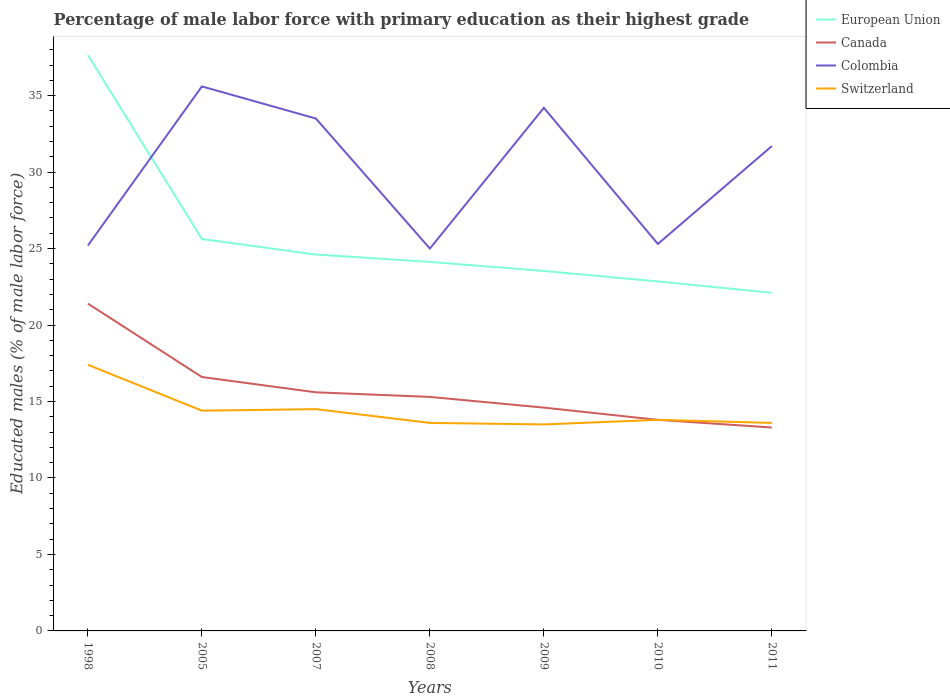Is the number of lines equal to the number of legend labels?
Offer a very short reply. Yes. Across all years, what is the maximum percentage of male labor force with primary education in European Union?
Offer a terse response. 22.11. What is the total percentage of male labor force with primary education in Canada in the graph?
Ensure brevity in your answer.  1.3. What is the difference between the highest and the second highest percentage of male labor force with primary education in Switzerland?
Offer a terse response. 3.9. What is the difference between the highest and the lowest percentage of male labor force with primary education in Colombia?
Provide a short and direct response. 4. Is the percentage of male labor force with primary education in Colombia strictly greater than the percentage of male labor force with primary education in European Union over the years?
Give a very brief answer. No. How many lines are there?
Your answer should be very brief. 4. How many years are there in the graph?
Provide a succinct answer. 7. Does the graph contain any zero values?
Make the answer very short. No. Does the graph contain grids?
Provide a short and direct response. No. Where does the legend appear in the graph?
Give a very brief answer. Top right. How are the legend labels stacked?
Provide a succinct answer. Vertical. What is the title of the graph?
Your answer should be compact. Percentage of male labor force with primary education as their highest grade. What is the label or title of the X-axis?
Your answer should be compact. Years. What is the label or title of the Y-axis?
Keep it short and to the point. Educated males (% of male labor force). What is the Educated males (% of male labor force) in European Union in 1998?
Offer a terse response. 37.64. What is the Educated males (% of male labor force) in Canada in 1998?
Your answer should be compact. 21.4. What is the Educated males (% of male labor force) in Colombia in 1998?
Make the answer very short. 25.2. What is the Educated males (% of male labor force) of Switzerland in 1998?
Your answer should be compact. 17.4. What is the Educated males (% of male labor force) in European Union in 2005?
Give a very brief answer. 25.62. What is the Educated males (% of male labor force) in Canada in 2005?
Offer a very short reply. 16.6. What is the Educated males (% of male labor force) in Colombia in 2005?
Provide a short and direct response. 35.6. What is the Educated males (% of male labor force) in Switzerland in 2005?
Give a very brief answer. 14.4. What is the Educated males (% of male labor force) of European Union in 2007?
Offer a terse response. 24.61. What is the Educated males (% of male labor force) of Canada in 2007?
Provide a succinct answer. 15.6. What is the Educated males (% of male labor force) in Colombia in 2007?
Provide a succinct answer. 33.5. What is the Educated males (% of male labor force) of European Union in 2008?
Your response must be concise. 24.13. What is the Educated males (% of male labor force) in Canada in 2008?
Your response must be concise. 15.3. What is the Educated males (% of male labor force) in Colombia in 2008?
Your answer should be compact. 25. What is the Educated males (% of male labor force) of Switzerland in 2008?
Ensure brevity in your answer.  13.6. What is the Educated males (% of male labor force) in European Union in 2009?
Make the answer very short. 23.53. What is the Educated males (% of male labor force) of Canada in 2009?
Ensure brevity in your answer.  14.6. What is the Educated males (% of male labor force) of Colombia in 2009?
Offer a very short reply. 34.2. What is the Educated males (% of male labor force) in European Union in 2010?
Provide a short and direct response. 22.85. What is the Educated males (% of male labor force) in Canada in 2010?
Your answer should be compact. 13.8. What is the Educated males (% of male labor force) of Colombia in 2010?
Give a very brief answer. 25.3. What is the Educated males (% of male labor force) in Switzerland in 2010?
Make the answer very short. 13.8. What is the Educated males (% of male labor force) in European Union in 2011?
Provide a short and direct response. 22.11. What is the Educated males (% of male labor force) in Canada in 2011?
Make the answer very short. 13.3. What is the Educated males (% of male labor force) of Colombia in 2011?
Provide a short and direct response. 31.7. What is the Educated males (% of male labor force) of Switzerland in 2011?
Your answer should be very brief. 13.6. Across all years, what is the maximum Educated males (% of male labor force) of European Union?
Make the answer very short. 37.64. Across all years, what is the maximum Educated males (% of male labor force) of Canada?
Offer a terse response. 21.4. Across all years, what is the maximum Educated males (% of male labor force) in Colombia?
Ensure brevity in your answer.  35.6. Across all years, what is the maximum Educated males (% of male labor force) of Switzerland?
Offer a terse response. 17.4. Across all years, what is the minimum Educated males (% of male labor force) of European Union?
Keep it short and to the point. 22.11. Across all years, what is the minimum Educated males (% of male labor force) in Canada?
Offer a very short reply. 13.3. What is the total Educated males (% of male labor force) of European Union in the graph?
Provide a short and direct response. 180.48. What is the total Educated males (% of male labor force) in Canada in the graph?
Your response must be concise. 110.6. What is the total Educated males (% of male labor force) of Colombia in the graph?
Your answer should be very brief. 210.5. What is the total Educated males (% of male labor force) in Switzerland in the graph?
Your answer should be very brief. 100.8. What is the difference between the Educated males (% of male labor force) of European Union in 1998 and that in 2005?
Your response must be concise. 12.02. What is the difference between the Educated males (% of male labor force) of Canada in 1998 and that in 2005?
Keep it short and to the point. 4.8. What is the difference between the Educated males (% of male labor force) in Colombia in 1998 and that in 2005?
Provide a succinct answer. -10.4. What is the difference between the Educated males (% of male labor force) in European Union in 1998 and that in 2007?
Give a very brief answer. 13.04. What is the difference between the Educated males (% of male labor force) of Canada in 1998 and that in 2007?
Give a very brief answer. 5.8. What is the difference between the Educated males (% of male labor force) of Switzerland in 1998 and that in 2007?
Your answer should be very brief. 2.9. What is the difference between the Educated males (% of male labor force) in European Union in 1998 and that in 2008?
Your answer should be compact. 13.52. What is the difference between the Educated males (% of male labor force) of Colombia in 1998 and that in 2008?
Make the answer very short. 0.2. What is the difference between the Educated males (% of male labor force) of Switzerland in 1998 and that in 2008?
Your answer should be very brief. 3.8. What is the difference between the Educated males (% of male labor force) of European Union in 1998 and that in 2009?
Keep it short and to the point. 14.11. What is the difference between the Educated males (% of male labor force) of Canada in 1998 and that in 2009?
Provide a short and direct response. 6.8. What is the difference between the Educated males (% of male labor force) in Colombia in 1998 and that in 2009?
Ensure brevity in your answer.  -9. What is the difference between the Educated males (% of male labor force) of European Union in 1998 and that in 2010?
Give a very brief answer. 14.79. What is the difference between the Educated males (% of male labor force) in Canada in 1998 and that in 2010?
Provide a succinct answer. 7.6. What is the difference between the Educated males (% of male labor force) in Colombia in 1998 and that in 2010?
Offer a very short reply. -0.1. What is the difference between the Educated males (% of male labor force) in Switzerland in 1998 and that in 2010?
Make the answer very short. 3.6. What is the difference between the Educated males (% of male labor force) in European Union in 1998 and that in 2011?
Make the answer very short. 15.54. What is the difference between the Educated males (% of male labor force) of European Union in 2005 and that in 2007?
Offer a terse response. 1.02. What is the difference between the Educated males (% of male labor force) in Switzerland in 2005 and that in 2007?
Make the answer very short. -0.1. What is the difference between the Educated males (% of male labor force) of European Union in 2005 and that in 2008?
Offer a very short reply. 1.5. What is the difference between the Educated males (% of male labor force) of Canada in 2005 and that in 2008?
Provide a succinct answer. 1.3. What is the difference between the Educated males (% of male labor force) in European Union in 2005 and that in 2009?
Ensure brevity in your answer.  2.09. What is the difference between the Educated males (% of male labor force) of Colombia in 2005 and that in 2009?
Ensure brevity in your answer.  1.4. What is the difference between the Educated males (% of male labor force) of Switzerland in 2005 and that in 2009?
Your answer should be very brief. 0.9. What is the difference between the Educated males (% of male labor force) of European Union in 2005 and that in 2010?
Offer a very short reply. 2.78. What is the difference between the Educated males (% of male labor force) in Canada in 2005 and that in 2010?
Your response must be concise. 2.8. What is the difference between the Educated males (% of male labor force) of Switzerland in 2005 and that in 2010?
Make the answer very short. 0.6. What is the difference between the Educated males (% of male labor force) of European Union in 2005 and that in 2011?
Keep it short and to the point. 3.52. What is the difference between the Educated males (% of male labor force) of Canada in 2005 and that in 2011?
Give a very brief answer. 3.3. What is the difference between the Educated males (% of male labor force) in European Union in 2007 and that in 2008?
Offer a very short reply. 0.48. What is the difference between the Educated males (% of male labor force) in Colombia in 2007 and that in 2008?
Provide a short and direct response. 8.5. What is the difference between the Educated males (% of male labor force) in Switzerland in 2007 and that in 2008?
Provide a short and direct response. 0.9. What is the difference between the Educated males (% of male labor force) of European Union in 2007 and that in 2009?
Give a very brief answer. 1.07. What is the difference between the Educated males (% of male labor force) in European Union in 2007 and that in 2010?
Offer a very short reply. 1.76. What is the difference between the Educated males (% of male labor force) of Canada in 2007 and that in 2010?
Offer a very short reply. 1.8. What is the difference between the Educated males (% of male labor force) in Colombia in 2007 and that in 2010?
Offer a terse response. 8.2. What is the difference between the Educated males (% of male labor force) in Switzerland in 2007 and that in 2010?
Ensure brevity in your answer.  0.7. What is the difference between the Educated males (% of male labor force) of European Union in 2007 and that in 2011?
Provide a succinct answer. 2.5. What is the difference between the Educated males (% of male labor force) of European Union in 2008 and that in 2009?
Keep it short and to the point. 0.59. What is the difference between the Educated males (% of male labor force) in Colombia in 2008 and that in 2009?
Your answer should be compact. -9.2. What is the difference between the Educated males (% of male labor force) of European Union in 2008 and that in 2010?
Make the answer very short. 1.28. What is the difference between the Educated males (% of male labor force) of Switzerland in 2008 and that in 2010?
Ensure brevity in your answer.  -0.2. What is the difference between the Educated males (% of male labor force) of European Union in 2008 and that in 2011?
Provide a succinct answer. 2.02. What is the difference between the Educated males (% of male labor force) of Canada in 2008 and that in 2011?
Offer a terse response. 2. What is the difference between the Educated males (% of male labor force) of European Union in 2009 and that in 2010?
Your response must be concise. 0.69. What is the difference between the Educated males (% of male labor force) in Canada in 2009 and that in 2010?
Make the answer very short. 0.8. What is the difference between the Educated males (% of male labor force) in European Union in 2009 and that in 2011?
Offer a terse response. 1.43. What is the difference between the Educated males (% of male labor force) of Canada in 2009 and that in 2011?
Offer a very short reply. 1.3. What is the difference between the Educated males (% of male labor force) of Switzerland in 2009 and that in 2011?
Provide a short and direct response. -0.1. What is the difference between the Educated males (% of male labor force) in European Union in 2010 and that in 2011?
Your answer should be very brief. 0.74. What is the difference between the Educated males (% of male labor force) of European Union in 1998 and the Educated males (% of male labor force) of Canada in 2005?
Provide a short and direct response. 21.04. What is the difference between the Educated males (% of male labor force) of European Union in 1998 and the Educated males (% of male labor force) of Colombia in 2005?
Your answer should be compact. 2.04. What is the difference between the Educated males (% of male labor force) of European Union in 1998 and the Educated males (% of male labor force) of Switzerland in 2005?
Ensure brevity in your answer.  23.24. What is the difference between the Educated males (% of male labor force) in European Union in 1998 and the Educated males (% of male labor force) in Canada in 2007?
Keep it short and to the point. 22.04. What is the difference between the Educated males (% of male labor force) in European Union in 1998 and the Educated males (% of male labor force) in Colombia in 2007?
Offer a terse response. 4.14. What is the difference between the Educated males (% of male labor force) of European Union in 1998 and the Educated males (% of male labor force) of Switzerland in 2007?
Provide a short and direct response. 23.14. What is the difference between the Educated males (% of male labor force) of European Union in 1998 and the Educated males (% of male labor force) of Canada in 2008?
Give a very brief answer. 22.34. What is the difference between the Educated males (% of male labor force) in European Union in 1998 and the Educated males (% of male labor force) in Colombia in 2008?
Your answer should be very brief. 12.64. What is the difference between the Educated males (% of male labor force) in European Union in 1998 and the Educated males (% of male labor force) in Switzerland in 2008?
Ensure brevity in your answer.  24.04. What is the difference between the Educated males (% of male labor force) in Canada in 1998 and the Educated males (% of male labor force) in Colombia in 2008?
Offer a very short reply. -3.6. What is the difference between the Educated males (% of male labor force) of Colombia in 1998 and the Educated males (% of male labor force) of Switzerland in 2008?
Offer a very short reply. 11.6. What is the difference between the Educated males (% of male labor force) in European Union in 1998 and the Educated males (% of male labor force) in Canada in 2009?
Make the answer very short. 23.04. What is the difference between the Educated males (% of male labor force) of European Union in 1998 and the Educated males (% of male labor force) of Colombia in 2009?
Your answer should be compact. 3.44. What is the difference between the Educated males (% of male labor force) of European Union in 1998 and the Educated males (% of male labor force) of Switzerland in 2009?
Provide a succinct answer. 24.14. What is the difference between the Educated males (% of male labor force) of Colombia in 1998 and the Educated males (% of male labor force) of Switzerland in 2009?
Offer a very short reply. 11.7. What is the difference between the Educated males (% of male labor force) in European Union in 1998 and the Educated males (% of male labor force) in Canada in 2010?
Ensure brevity in your answer.  23.84. What is the difference between the Educated males (% of male labor force) in European Union in 1998 and the Educated males (% of male labor force) in Colombia in 2010?
Offer a very short reply. 12.34. What is the difference between the Educated males (% of male labor force) of European Union in 1998 and the Educated males (% of male labor force) of Switzerland in 2010?
Ensure brevity in your answer.  23.84. What is the difference between the Educated males (% of male labor force) in Canada in 1998 and the Educated males (% of male labor force) in Colombia in 2010?
Provide a succinct answer. -3.9. What is the difference between the Educated males (% of male labor force) of Colombia in 1998 and the Educated males (% of male labor force) of Switzerland in 2010?
Your answer should be very brief. 11.4. What is the difference between the Educated males (% of male labor force) in European Union in 1998 and the Educated males (% of male labor force) in Canada in 2011?
Your response must be concise. 24.34. What is the difference between the Educated males (% of male labor force) in European Union in 1998 and the Educated males (% of male labor force) in Colombia in 2011?
Your answer should be compact. 5.94. What is the difference between the Educated males (% of male labor force) in European Union in 1998 and the Educated males (% of male labor force) in Switzerland in 2011?
Your answer should be compact. 24.04. What is the difference between the Educated males (% of male labor force) of Canada in 1998 and the Educated males (% of male labor force) of Switzerland in 2011?
Ensure brevity in your answer.  7.8. What is the difference between the Educated males (% of male labor force) of European Union in 2005 and the Educated males (% of male labor force) of Canada in 2007?
Give a very brief answer. 10.02. What is the difference between the Educated males (% of male labor force) of European Union in 2005 and the Educated males (% of male labor force) of Colombia in 2007?
Ensure brevity in your answer.  -7.88. What is the difference between the Educated males (% of male labor force) of European Union in 2005 and the Educated males (% of male labor force) of Switzerland in 2007?
Provide a short and direct response. 11.12. What is the difference between the Educated males (% of male labor force) in Canada in 2005 and the Educated males (% of male labor force) in Colombia in 2007?
Provide a short and direct response. -16.9. What is the difference between the Educated males (% of male labor force) of Canada in 2005 and the Educated males (% of male labor force) of Switzerland in 2007?
Your answer should be very brief. 2.1. What is the difference between the Educated males (% of male labor force) of Colombia in 2005 and the Educated males (% of male labor force) of Switzerland in 2007?
Offer a very short reply. 21.1. What is the difference between the Educated males (% of male labor force) of European Union in 2005 and the Educated males (% of male labor force) of Canada in 2008?
Make the answer very short. 10.32. What is the difference between the Educated males (% of male labor force) of European Union in 2005 and the Educated males (% of male labor force) of Colombia in 2008?
Make the answer very short. 0.62. What is the difference between the Educated males (% of male labor force) in European Union in 2005 and the Educated males (% of male labor force) in Switzerland in 2008?
Make the answer very short. 12.02. What is the difference between the Educated males (% of male labor force) in Canada in 2005 and the Educated males (% of male labor force) in Colombia in 2008?
Give a very brief answer. -8.4. What is the difference between the Educated males (% of male labor force) of Canada in 2005 and the Educated males (% of male labor force) of Switzerland in 2008?
Provide a short and direct response. 3. What is the difference between the Educated males (% of male labor force) in European Union in 2005 and the Educated males (% of male labor force) in Canada in 2009?
Your response must be concise. 11.02. What is the difference between the Educated males (% of male labor force) in European Union in 2005 and the Educated males (% of male labor force) in Colombia in 2009?
Offer a terse response. -8.58. What is the difference between the Educated males (% of male labor force) of European Union in 2005 and the Educated males (% of male labor force) of Switzerland in 2009?
Your answer should be very brief. 12.12. What is the difference between the Educated males (% of male labor force) in Canada in 2005 and the Educated males (% of male labor force) in Colombia in 2009?
Your answer should be compact. -17.6. What is the difference between the Educated males (% of male labor force) of Canada in 2005 and the Educated males (% of male labor force) of Switzerland in 2009?
Make the answer very short. 3.1. What is the difference between the Educated males (% of male labor force) of Colombia in 2005 and the Educated males (% of male labor force) of Switzerland in 2009?
Offer a terse response. 22.1. What is the difference between the Educated males (% of male labor force) in European Union in 2005 and the Educated males (% of male labor force) in Canada in 2010?
Give a very brief answer. 11.82. What is the difference between the Educated males (% of male labor force) in European Union in 2005 and the Educated males (% of male labor force) in Colombia in 2010?
Ensure brevity in your answer.  0.32. What is the difference between the Educated males (% of male labor force) in European Union in 2005 and the Educated males (% of male labor force) in Switzerland in 2010?
Provide a short and direct response. 11.82. What is the difference between the Educated males (% of male labor force) in Canada in 2005 and the Educated males (% of male labor force) in Colombia in 2010?
Make the answer very short. -8.7. What is the difference between the Educated males (% of male labor force) of Colombia in 2005 and the Educated males (% of male labor force) of Switzerland in 2010?
Make the answer very short. 21.8. What is the difference between the Educated males (% of male labor force) of European Union in 2005 and the Educated males (% of male labor force) of Canada in 2011?
Your answer should be very brief. 12.32. What is the difference between the Educated males (% of male labor force) in European Union in 2005 and the Educated males (% of male labor force) in Colombia in 2011?
Ensure brevity in your answer.  -6.08. What is the difference between the Educated males (% of male labor force) in European Union in 2005 and the Educated males (% of male labor force) in Switzerland in 2011?
Provide a succinct answer. 12.02. What is the difference between the Educated males (% of male labor force) of Canada in 2005 and the Educated males (% of male labor force) of Colombia in 2011?
Provide a short and direct response. -15.1. What is the difference between the Educated males (% of male labor force) of Colombia in 2005 and the Educated males (% of male labor force) of Switzerland in 2011?
Your answer should be compact. 22. What is the difference between the Educated males (% of male labor force) in European Union in 2007 and the Educated males (% of male labor force) in Canada in 2008?
Offer a terse response. 9.31. What is the difference between the Educated males (% of male labor force) of European Union in 2007 and the Educated males (% of male labor force) of Colombia in 2008?
Give a very brief answer. -0.39. What is the difference between the Educated males (% of male labor force) in European Union in 2007 and the Educated males (% of male labor force) in Switzerland in 2008?
Give a very brief answer. 11.01. What is the difference between the Educated males (% of male labor force) in Canada in 2007 and the Educated males (% of male labor force) in Colombia in 2008?
Give a very brief answer. -9.4. What is the difference between the Educated males (% of male labor force) of Canada in 2007 and the Educated males (% of male labor force) of Switzerland in 2008?
Offer a very short reply. 2. What is the difference between the Educated males (% of male labor force) in Colombia in 2007 and the Educated males (% of male labor force) in Switzerland in 2008?
Offer a very short reply. 19.9. What is the difference between the Educated males (% of male labor force) in European Union in 2007 and the Educated males (% of male labor force) in Canada in 2009?
Keep it short and to the point. 10.01. What is the difference between the Educated males (% of male labor force) in European Union in 2007 and the Educated males (% of male labor force) in Colombia in 2009?
Offer a terse response. -9.59. What is the difference between the Educated males (% of male labor force) in European Union in 2007 and the Educated males (% of male labor force) in Switzerland in 2009?
Your response must be concise. 11.11. What is the difference between the Educated males (% of male labor force) of Canada in 2007 and the Educated males (% of male labor force) of Colombia in 2009?
Keep it short and to the point. -18.6. What is the difference between the Educated males (% of male labor force) of Canada in 2007 and the Educated males (% of male labor force) of Switzerland in 2009?
Provide a short and direct response. 2.1. What is the difference between the Educated males (% of male labor force) in European Union in 2007 and the Educated males (% of male labor force) in Canada in 2010?
Provide a short and direct response. 10.81. What is the difference between the Educated males (% of male labor force) of European Union in 2007 and the Educated males (% of male labor force) of Colombia in 2010?
Make the answer very short. -0.69. What is the difference between the Educated males (% of male labor force) of European Union in 2007 and the Educated males (% of male labor force) of Switzerland in 2010?
Keep it short and to the point. 10.81. What is the difference between the Educated males (% of male labor force) of Canada in 2007 and the Educated males (% of male labor force) of Switzerland in 2010?
Offer a very short reply. 1.8. What is the difference between the Educated males (% of male labor force) in Colombia in 2007 and the Educated males (% of male labor force) in Switzerland in 2010?
Offer a terse response. 19.7. What is the difference between the Educated males (% of male labor force) in European Union in 2007 and the Educated males (% of male labor force) in Canada in 2011?
Your answer should be very brief. 11.31. What is the difference between the Educated males (% of male labor force) of European Union in 2007 and the Educated males (% of male labor force) of Colombia in 2011?
Give a very brief answer. -7.09. What is the difference between the Educated males (% of male labor force) of European Union in 2007 and the Educated males (% of male labor force) of Switzerland in 2011?
Offer a very short reply. 11.01. What is the difference between the Educated males (% of male labor force) in Canada in 2007 and the Educated males (% of male labor force) in Colombia in 2011?
Give a very brief answer. -16.1. What is the difference between the Educated males (% of male labor force) in Canada in 2007 and the Educated males (% of male labor force) in Switzerland in 2011?
Ensure brevity in your answer.  2. What is the difference between the Educated males (% of male labor force) in Colombia in 2007 and the Educated males (% of male labor force) in Switzerland in 2011?
Ensure brevity in your answer.  19.9. What is the difference between the Educated males (% of male labor force) of European Union in 2008 and the Educated males (% of male labor force) of Canada in 2009?
Keep it short and to the point. 9.53. What is the difference between the Educated males (% of male labor force) in European Union in 2008 and the Educated males (% of male labor force) in Colombia in 2009?
Provide a succinct answer. -10.07. What is the difference between the Educated males (% of male labor force) of European Union in 2008 and the Educated males (% of male labor force) of Switzerland in 2009?
Keep it short and to the point. 10.63. What is the difference between the Educated males (% of male labor force) in Canada in 2008 and the Educated males (% of male labor force) in Colombia in 2009?
Your response must be concise. -18.9. What is the difference between the Educated males (% of male labor force) of Canada in 2008 and the Educated males (% of male labor force) of Switzerland in 2009?
Make the answer very short. 1.8. What is the difference between the Educated males (% of male labor force) of European Union in 2008 and the Educated males (% of male labor force) of Canada in 2010?
Ensure brevity in your answer.  10.33. What is the difference between the Educated males (% of male labor force) in European Union in 2008 and the Educated males (% of male labor force) in Colombia in 2010?
Offer a terse response. -1.17. What is the difference between the Educated males (% of male labor force) in European Union in 2008 and the Educated males (% of male labor force) in Switzerland in 2010?
Offer a terse response. 10.33. What is the difference between the Educated males (% of male labor force) in Canada in 2008 and the Educated males (% of male labor force) in Colombia in 2010?
Offer a terse response. -10. What is the difference between the Educated males (% of male labor force) in Canada in 2008 and the Educated males (% of male labor force) in Switzerland in 2010?
Your response must be concise. 1.5. What is the difference between the Educated males (% of male labor force) in European Union in 2008 and the Educated males (% of male labor force) in Canada in 2011?
Your answer should be compact. 10.83. What is the difference between the Educated males (% of male labor force) of European Union in 2008 and the Educated males (% of male labor force) of Colombia in 2011?
Provide a short and direct response. -7.57. What is the difference between the Educated males (% of male labor force) of European Union in 2008 and the Educated males (% of male labor force) of Switzerland in 2011?
Provide a succinct answer. 10.53. What is the difference between the Educated males (% of male labor force) in Canada in 2008 and the Educated males (% of male labor force) in Colombia in 2011?
Provide a short and direct response. -16.4. What is the difference between the Educated males (% of male labor force) of Colombia in 2008 and the Educated males (% of male labor force) of Switzerland in 2011?
Provide a succinct answer. 11.4. What is the difference between the Educated males (% of male labor force) of European Union in 2009 and the Educated males (% of male labor force) of Canada in 2010?
Give a very brief answer. 9.73. What is the difference between the Educated males (% of male labor force) of European Union in 2009 and the Educated males (% of male labor force) of Colombia in 2010?
Your answer should be compact. -1.77. What is the difference between the Educated males (% of male labor force) in European Union in 2009 and the Educated males (% of male labor force) in Switzerland in 2010?
Your response must be concise. 9.73. What is the difference between the Educated males (% of male labor force) of Canada in 2009 and the Educated males (% of male labor force) of Colombia in 2010?
Make the answer very short. -10.7. What is the difference between the Educated males (% of male labor force) of Colombia in 2009 and the Educated males (% of male labor force) of Switzerland in 2010?
Offer a terse response. 20.4. What is the difference between the Educated males (% of male labor force) in European Union in 2009 and the Educated males (% of male labor force) in Canada in 2011?
Offer a very short reply. 10.23. What is the difference between the Educated males (% of male labor force) of European Union in 2009 and the Educated males (% of male labor force) of Colombia in 2011?
Keep it short and to the point. -8.17. What is the difference between the Educated males (% of male labor force) of European Union in 2009 and the Educated males (% of male labor force) of Switzerland in 2011?
Ensure brevity in your answer.  9.93. What is the difference between the Educated males (% of male labor force) of Canada in 2009 and the Educated males (% of male labor force) of Colombia in 2011?
Provide a short and direct response. -17.1. What is the difference between the Educated males (% of male labor force) of Colombia in 2009 and the Educated males (% of male labor force) of Switzerland in 2011?
Offer a very short reply. 20.6. What is the difference between the Educated males (% of male labor force) in European Union in 2010 and the Educated males (% of male labor force) in Canada in 2011?
Offer a terse response. 9.55. What is the difference between the Educated males (% of male labor force) in European Union in 2010 and the Educated males (% of male labor force) in Colombia in 2011?
Your answer should be very brief. -8.85. What is the difference between the Educated males (% of male labor force) of European Union in 2010 and the Educated males (% of male labor force) of Switzerland in 2011?
Your answer should be very brief. 9.25. What is the difference between the Educated males (% of male labor force) in Canada in 2010 and the Educated males (% of male labor force) in Colombia in 2011?
Your response must be concise. -17.9. What is the difference between the Educated males (% of male labor force) of Colombia in 2010 and the Educated males (% of male labor force) of Switzerland in 2011?
Provide a short and direct response. 11.7. What is the average Educated males (% of male labor force) in European Union per year?
Your response must be concise. 25.78. What is the average Educated males (% of male labor force) in Colombia per year?
Your answer should be compact. 30.07. What is the average Educated males (% of male labor force) in Switzerland per year?
Offer a very short reply. 14.4. In the year 1998, what is the difference between the Educated males (% of male labor force) of European Union and Educated males (% of male labor force) of Canada?
Offer a terse response. 16.24. In the year 1998, what is the difference between the Educated males (% of male labor force) in European Union and Educated males (% of male labor force) in Colombia?
Offer a very short reply. 12.44. In the year 1998, what is the difference between the Educated males (% of male labor force) of European Union and Educated males (% of male labor force) of Switzerland?
Make the answer very short. 20.24. In the year 1998, what is the difference between the Educated males (% of male labor force) in Colombia and Educated males (% of male labor force) in Switzerland?
Provide a short and direct response. 7.8. In the year 2005, what is the difference between the Educated males (% of male labor force) in European Union and Educated males (% of male labor force) in Canada?
Provide a succinct answer. 9.02. In the year 2005, what is the difference between the Educated males (% of male labor force) of European Union and Educated males (% of male labor force) of Colombia?
Your answer should be very brief. -9.98. In the year 2005, what is the difference between the Educated males (% of male labor force) in European Union and Educated males (% of male labor force) in Switzerland?
Offer a terse response. 11.22. In the year 2005, what is the difference between the Educated males (% of male labor force) of Colombia and Educated males (% of male labor force) of Switzerland?
Make the answer very short. 21.2. In the year 2007, what is the difference between the Educated males (% of male labor force) in European Union and Educated males (% of male labor force) in Canada?
Provide a succinct answer. 9.01. In the year 2007, what is the difference between the Educated males (% of male labor force) in European Union and Educated males (% of male labor force) in Colombia?
Provide a succinct answer. -8.89. In the year 2007, what is the difference between the Educated males (% of male labor force) of European Union and Educated males (% of male labor force) of Switzerland?
Provide a short and direct response. 10.11. In the year 2007, what is the difference between the Educated males (% of male labor force) of Canada and Educated males (% of male labor force) of Colombia?
Offer a terse response. -17.9. In the year 2007, what is the difference between the Educated males (% of male labor force) in Canada and Educated males (% of male labor force) in Switzerland?
Make the answer very short. 1.1. In the year 2007, what is the difference between the Educated males (% of male labor force) of Colombia and Educated males (% of male labor force) of Switzerland?
Keep it short and to the point. 19. In the year 2008, what is the difference between the Educated males (% of male labor force) in European Union and Educated males (% of male labor force) in Canada?
Your answer should be compact. 8.83. In the year 2008, what is the difference between the Educated males (% of male labor force) in European Union and Educated males (% of male labor force) in Colombia?
Offer a terse response. -0.87. In the year 2008, what is the difference between the Educated males (% of male labor force) in European Union and Educated males (% of male labor force) in Switzerland?
Give a very brief answer. 10.53. In the year 2008, what is the difference between the Educated males (% of male labor force) of Canada and Educated males (% of male labor force) of Switzerland?
Your answer should be very brief. 1.7. In the year 2009, what is the difference between the Educated males (% of male labor force) of European Union and Educated males (% of male labor force) of Canada?
Provide a short and direct response. 8.93. In the year 2009, what is the difference between the Educated males (% of male labor force) of European Union and Educated males (% of male labor force) of Colombia?
Your response must be concise. -10.67. In the year 2009, what is the difference between the Educated males (% of male labor force) of European Union and Educated males (% of male labor force) of Switzerland?
Your answer should be very brief. 10.03. In the year 2009, what is the difference between the Educated males (% of male labor force) in Canada and Educated males (% of male labor force) in Colombia?
Give a very brief answer. -19.6. In the year 2009, what is the difference between the Educated males (% of male labor force) of Canada and Educated males (% of male labor force) of Switzerland?
Provide a short and direct response. 1.1. In the year 2009, what is the difference between the Educated males (% of male labor force) in Colombia and Educated males (% of male labor force) in Switzerland?
Provide a short and direct response. 20.7. In the year 2010, what is the difference between the Educated males (% of male labor force) of European Union and Educated males (% of male labor force) of Canada?
Offer a very short reply. 9.05. In the year 2010, what is the difference between the Educated males (% of male labor force) of European Union and Educated males (% of male labor force) of Colombia?
Keep it short and to the point. -2.45. In the year 2010, what is the difference between the Educated males (% of male labor force) in European Union and Educated males (% of male labor force) in Switzerland?
Your answer should be very brief. 9.05. In the year 2011, what is the difference between the Educated males (% of male labor force) of European Union and Educated males (% of male labor force) of Canada?
Your response must be concise. 8.81. In the year 2011, what is the difference between the Educated males (% of male labor force) in European Union and Educated males (% of male labor force) in Colombia?
Keep it short and to the point. -9.59. In the year 2011, what is the difference between the Educated males (% of male labor force) in European Union and Educated males (% of male labor force) in Switzerland?
Offer a terse response. 8.51. In the year 2011, what is the difference between the Educated males (% of male labor force) in Canada and Educated males (% of male labor force) in Colombia?
Your answer should be very brief. -18.4. What is the ratio of the Educated males (% of male labor force) in European Union in 1998 to that in 2005?
Your answer should be very brief. 1.47. What is the ratio of the Educated males (% of male labor force) of Canada in 1998 to that in 2005?
Your answer should be very brief. 1.29. What is the ratio of the Educated males (% of male labor force) in Colombia in 1998 to that in 2005?
Offer a terse response. 0.71. What is the ratio of the Educated males (% of male labor force) of Switzerland in 1998 to that in 2005?
Make the answer very short. 1.21. What is the ratio of the Educated males (% of male labor force) in European Union in 1998 to that in 2007?
Make the answer very short. 1.53. What is the ratio of the Educated males (% of male labor force) in Canada in 1998 to that in 2007?
Your answer should be very brief. 1.37. What is the ratio of the Educated males (% of male labor force) of Colombia in 1998 to that in 2007?
Your response must be concise. 0.75. What is the ratio of the Educated males (% of male labor force) in Switzerland in 1998 to that in 2007?
Make the answer very short. 1.2. What is the ratio of the Educated males (% of male labor force) of European Union in 1998 to that in 2008?
Your answer should be very brief. 1.56. What is the ratio of the Educated males (% of male labor force) of Canada in 1998 to that in 2008?
Your answer should be compact. 1.4. What is the ratio of the Educated males (% of male labor force) in Colombia in 1998 to that in 2008?
Your answer should be compact. 1.01. What is the ratio of the Educated males (% of male labor force) of Switzerland in 1998 to that in 2008?
Offer a terse response. 1.28. What is the ratio of the Educated males (% of male labor force) of European Union in 1998 to that in 2009?
Make the answer very short. 1.6. What is the ratio of the Educated males (% of male labor force) of Canada in 1998 to that in 2009?
Make the answer very short. 1.47. What is the ratio of the Educated males (% of male labor force) in Colombia in 1998 to that in 2009?
Ensure brevity in your answer.  0.74. What is the ratio of the Educated males (% of male labor force) of Switzerland in 1998 to that in 2009?
Give a very brief answer. 1.29. What is the ratio of the Educated males (% of male labor force) in European Union in 1998 to that in 2010?
Keep it short and to the point. 1.65. What is the ratio of the Educated males (% of male labor force) in Canada in 1998 to that in 2010?
Provide a succinct answer. 1.55. What is the ratio of the Educated males (% of male labor force) of Switzerland in 1998 to that in 2010?
Your answer should be very brief. 1.26. What is the ratio of the Educated males (% of male labor force) in European Union in 1998 to that in 2011?
Make the answer very short. 1.7. What is the ratio of the Educated males (% of male labor force) of Canada in 1998 to that in 2011?
Offer a very short reply. 1.61. What is the ratio of the Educated males (% of male labor force) in Colombia in 1998 to that in 2011?
Offer a terse response. 0.8. What is the ratio of the Educated males (% of male labor force) in Switzerland in 1998 to that in 2011?
Your answer should be very brief. 1.28. What is the ratio of the Educated males (% of male labor force) of European Union in 2005 to that in 2007?
Provide a succinct answer. 1.04. What is the ratio of the Educated males (% of male labor force) of Canada in 2005 to that in 2007?
Provide a short and direct response. 1.06. What is the ratio of the Educated males (% of male labor force) in Colombia in 2005 to that in 2007?
Offer a terse response. 1.06. What is the ratio of the Educated males (% of male labor force) in European Union in 2005 to that in 2008?
Your answer should be very brief. 1.06. What is the ratio of the Educated males (% of male labor force) of Canada in 2005 to that in 2008?
Offer a very short reply. 1.08. What is the ratio of the Educated males (% of male labor force) in Colombia in 2005 to that in 2008?
Provide a succinct answer. 1.42. What is the ratio of the Educated males (% of male labor force) of Switzerland in 2005 to that in 2008?
Give a very brief answer. 1.06. What is the ratio of the Educated males (% of male labor force) of European Union in 2005 to that in 2009?
Provide a short and direct response. 1.09. What is the ratio of the Educated males (% of male labor force) in Canada in 2005 to that in 2009?
Ensure brevity in your answer.  1.14. What is the ratio of the Educated males (% of male labor force) in Colombia in 2005 to that in 2009?
Keep it short and to the point. 1.04. What is the ratio of the Educated males (% of male labor force) in Switzerland in 2005 to that in 2009?
Your answer should be compact. 1.07. What is the ratio of the Educated males (% of male labor force) of European Union in 2005 to that in 2010?
Ensure brevity in your answer.  1.12. What is the ratio of the Educated males (% of male labor force) of Canada in 2005 to that in 2010?
Provide a succinct answer. 1.2. What is the ratio of the Educated males (% of male labor force) of Colombia in 2005 to that in 2010?
Keep it short and to the point. 1.41. What is the ratio of the Educated males (% of male labor force) of Switzerland in 2005 to that in 2010?
Offer a terse response. 1.04. What is the ratio of the Educated males (% of male labor force) of European Union in 2005 to that in 2011?
Offer a very short reply. 1.16. What is the ratio of the Educated males (% of male labor force) of Canada in 2005 to that in 2011?
Your answer should be very brief. 1.25. What is the ratio of the Educated males (% of male labor force) of Colombia in 2005 to that in 2011?
Offer a very short reply. 1.12. What is the ratio of the Educated males (% of male labor force) of Switzerland in 2005 to that in 2011?
Provide a succinct answer. 1.06. What is the ratio of the Educated males (% of male labor force) in European Union in 2007 to that in 2008?
Your answer should be very brief. 1.02. What is the ratio of the Educated males (% of male labor force) in Canada in 2007 to that in 2008?
Ensure brevity in your answer.  1.02. What is the ratio of the Educated males (% of male labor force) in Colombia in 2007 to that in 2008?
Offer a terse response. 1.34. What is the ratio of the Educated males (% of male labor force) of Switzerland in 2007 to that in 2008?
Make the answer very short. 1.07. What is the ratio of the Educated males (% of male labor force) in European Union in 2007 to that in 2009?
Provide a succinct answer. 1.05. What is the ratio of the Educated males (% of male labor force) of Canada in 2007 to that in 2009?
Your response must be concise. 1.07. What is the ratio of the Educated males (% of male labor force) in Colombia in 2007 to that in 2009?
Give a very brief answer. 0.98. What is the ratio of the Educated males (% of male labor force) of Switzerland in 2007 to that in 2009?
Keep it short and to the point. 1.07. What is the ratio of the Educated males (% of male labor force) of European Union in 2007 to that in 2010?
Your answer should be compact. 1.08. What is the ratio of the Educated males (% of male labor force) in Canada in 2007 to that in 2010?
Provide a succinct answer. 1.13. What is the ratio of the Educated males (% of male labor force) of Colombia in 2007 to that in 2010?
Give a very brief answer. 1.32. What is the ratio of the Educated males (% of male labor force) of Switzerland in 2007 to that in 2010?
Offer a terse response. 1.05. What is the ratio of the Educated males (% of male labor force) in European Union in 2007 to that in 2011?
Your answer should be very brief. 1.11. What is the ratio of the Educated males (% of male labor force) in Canada in 2007 to that in 2011?
Provide a short and direct response. 1.17. What is the ratio of the Educated males (% of male labor force) of Colombia in 2007 to that in 2011?
Keep it short and to the point. 1.06. What is the ratio of the Educated males (% of male labor force) in Switzerland in 2007 to that in 2011?
Make the answer very short. 1.07. What is the ratio of the Educated males (% of male labor force) in European Union in 2008 to that in 2009?
Provide a short and direct response. 1.03. What is the ratio of the Educated males (% of male labor force) of Canada in 2008 to that in 2009?
Give a very brief answer. 1.05. What is the ratio of the Educated males (% of male labor force) of Colombia in 2008 to that in 2009?
Keep it short and to the point. 0.73. What is the ratio of the Educated males (% of male labor force) of Switzerland in 2008 to that in 2009?
Your response must be concise. 1.01. What is the ratio of the Educated males (% of male labor force) of European Union in 2008 to that in 2010?
Your answer should be compact. 1.06. What is the ratio of the Educated males (% of male labor force) of Canada in 2008 to that in 2010?
Keep it short and to the point. 1.11. What is the ratio of the Educated males (% of male labor force) of Colombia in 2008 to that in 2010?
Ensure brevity in your answer.  0.99. What is the ratio of the Educated males (% of male labor force) of Switzerland in 2008 to that in 2010?
Make the answer very short. 0.99. What is the ratio of the Educated males (% of male labor force) in European Union in 2008 to that in 2011?
Your answer should be very brief. 1.09. What is the ratio of the Educated males (% of male labor force) of Canada in 2008 to that in 2011?
Provide a succinct answer. 1.15. What is the ratio of the Educated males (% of male labor force) in Colombia in 2008 to that in 2011?
Your answer should be very brief. 0.79. What is the ratio of the Educated males (% of male labor force) of Switzerland in 2008 to that in 2011?
Provide a succinct answer. 1. What is the ratio of the Educated males (% of male labor force) in Canada in 2009 to that in 2010?
Ensure brevity in your answer.  1.06. What is the ratio of the Educated males (% of male labor force) in Colombia in 2009 to that in 2010?
Offer a terse response. 1.35. What is the ratio of the Educated males (% of male labor force) of Switzerland in 2009 to that in 2010?
Offer a terse response. 0.98. What is the ratio of the Educated males (% of male labor force) of European Union in 2009 to that in 2011?
Keep it short and to the point. 1.06. What is the ratio of the Educated males (% of male labor force) of Canada in 2009 to that in 2011?
Your answer should be compact. 1.1. What is the ratio of the Educated males (% of male labor force) in Colombia in 2009 to that in 2011?
Your response must be concise. 1.08. What is the ratio of the Educated males (% of male labor force) in European Union in 2010 to that in 2011?
Give a very brief answer. 1.03. What is the ratio of the Educated males (% of male labor force) in Canada in 2010 to that in 2011?
Provide a short and direct response. 1.04. What is the ratio of the Educated males (% of male labor force) of Colombia in 2010 to that in 2011?
Keep it short and to the point. 0.8. What is the ratio of the Educated males (% of male labor force) of Switzerland in 2010 to that in 2011?
Offer a very short reply. 1.01. What is the difference between the highest and the second highest Educated males (% of male labor force) in European Union?
Your response must be concise. 12.02. What is the difference between the highest and the second highest Educated males (% of male labor force) of Colombia?
Offer a very short reply. 1.4. What is the difference between the highest and the lowest Educated males (% of male labor force) of European Union?
Your answer should be compact. 15.54. What is the difference between the highest and the lowest Educated males (% of male labor force) of Canada?
Give a very brief answer. 8.1. 